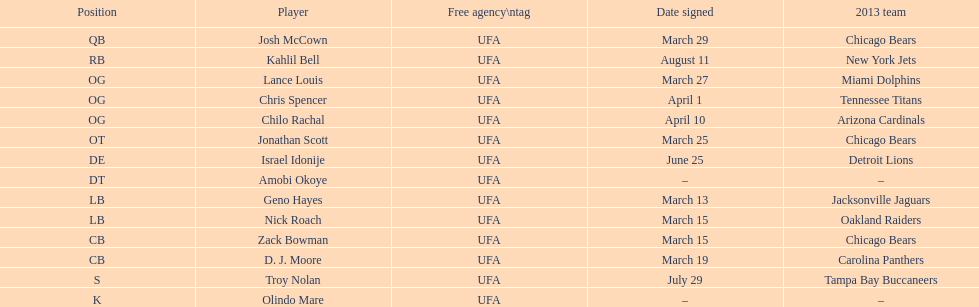Signed the same day as "april 1st pranks." Chris Spencer. 